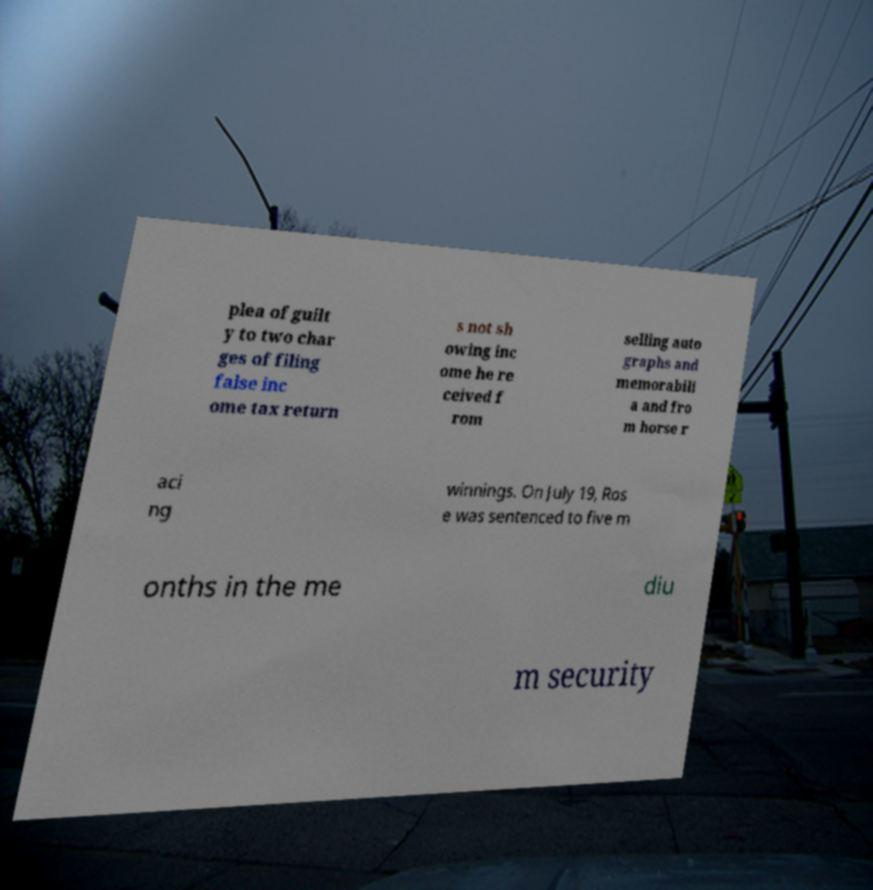Can you accurately transcribe the text from the provided image for me? plea of guilt y to two char ges of filing false inc ome tax return s not sh owing inc ome he re ceived f rom selling auto graphs and memorabili a and fro m horse r aci ng winnings. On July 19, Ros e was sentenced to five m onths in the me diu m security 